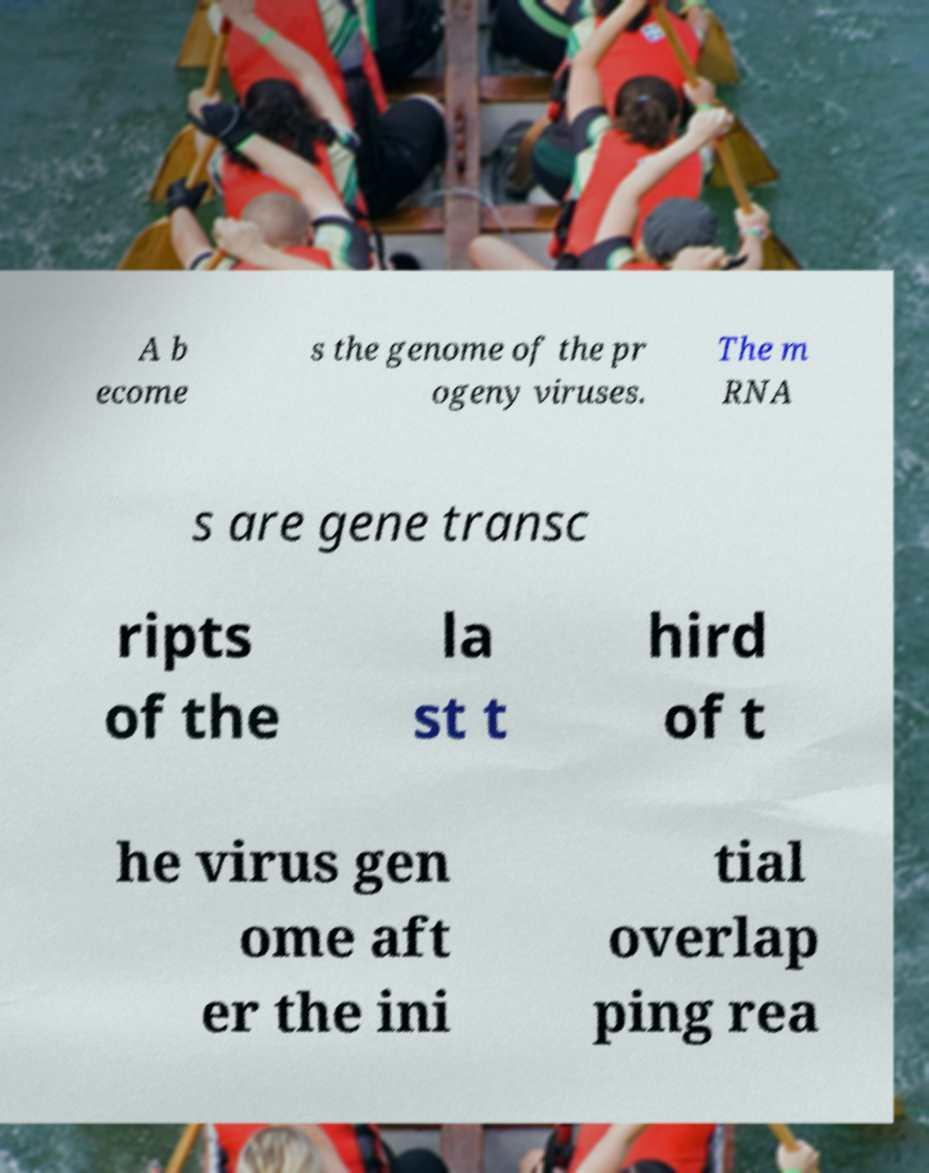Please read and relay the text visible in this image. What does it say? A b ecome s the genome of the pr ogeny viruses. The m RNA s are gene transc ripts of the la st t hird of t he virus gen ome aft er the ini tial overlap ping rea 